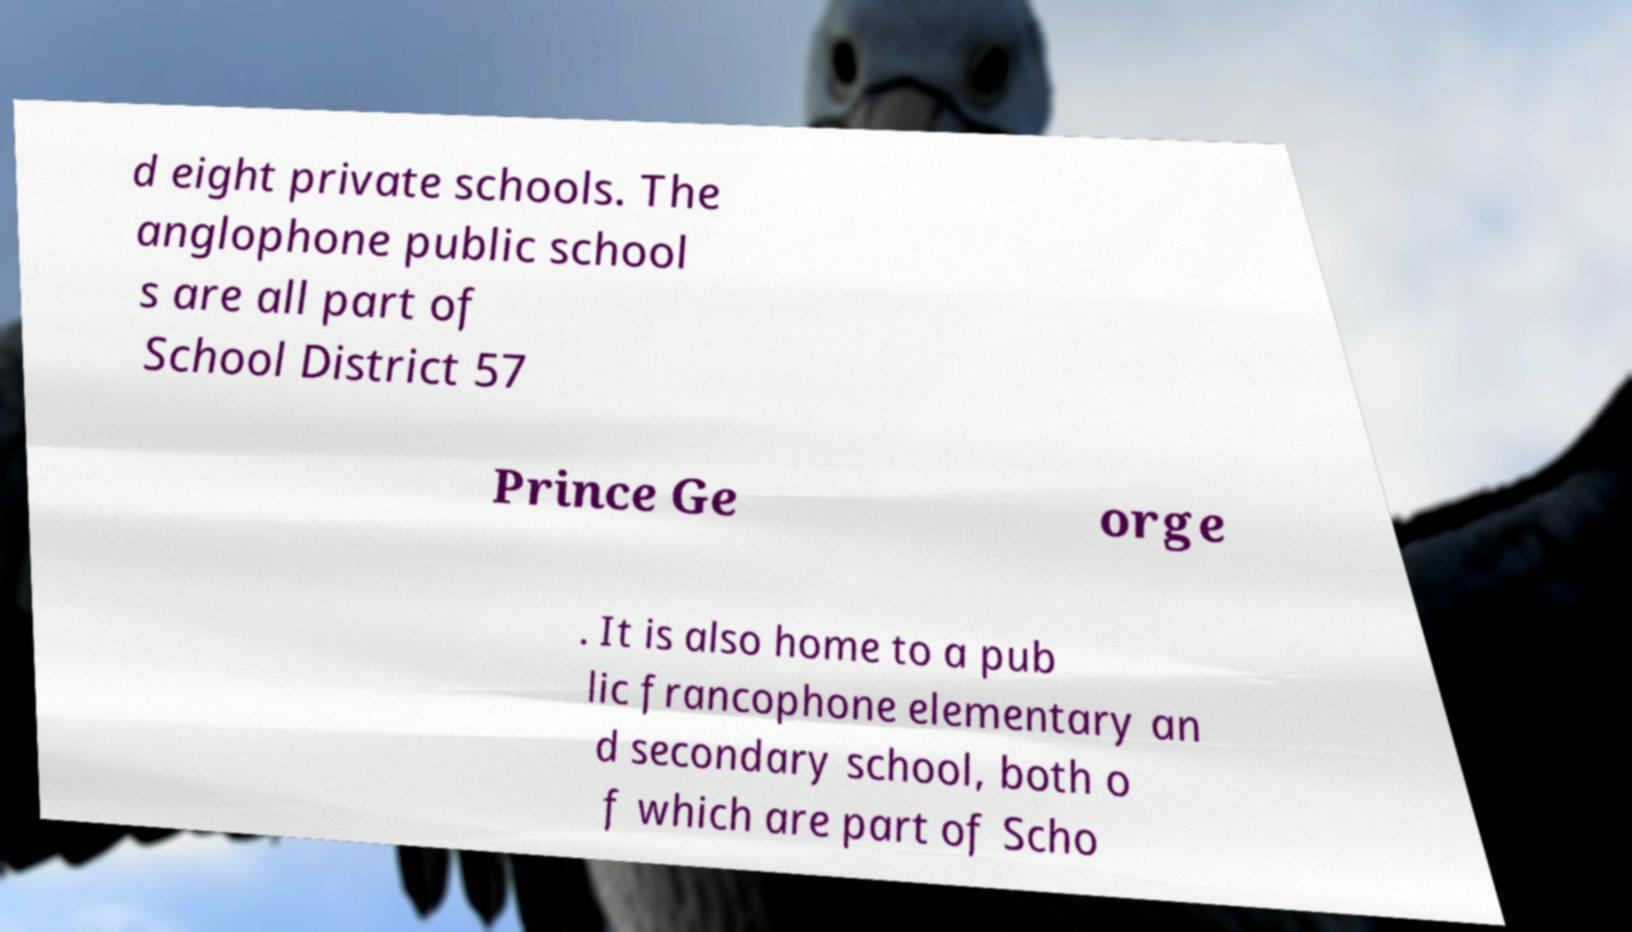Please identify and transcribe the text found in this image. d eight private schools. The anglophone public school s are all part of School District 57 Prince Ge orge . It is also home to a pub lic francophone elementary an d secondary school, both o f which are part of Scho 